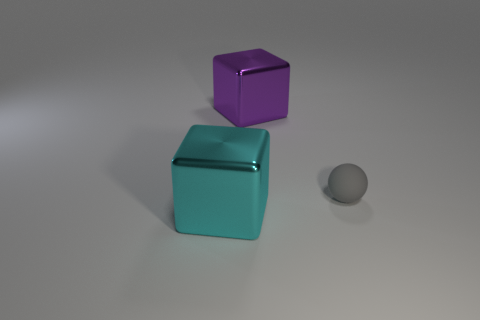Add 2 tiny blue cubes. How many objects exist? 5 Subtract all blocks. How many objects are left? 1 Add 2 tiny things. How many tiny things exist? 3 Subtract 0 blue spheres. How many objects are left? 3 Subtract all tiny matte things. Subtract all tiny gray things. How many objects are left? 1 Add 1 purple metallic cubes. How many purple metallic cubes are left? 2 